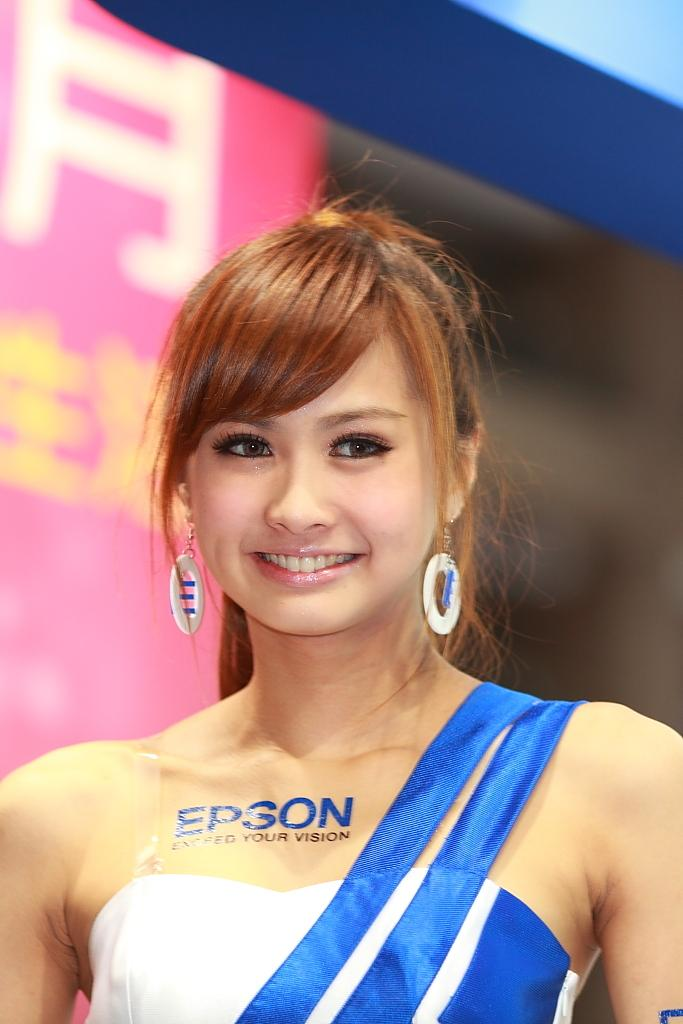<image>
Render a clear and concise summary of the photo. a lady that has Epson written on her dress 